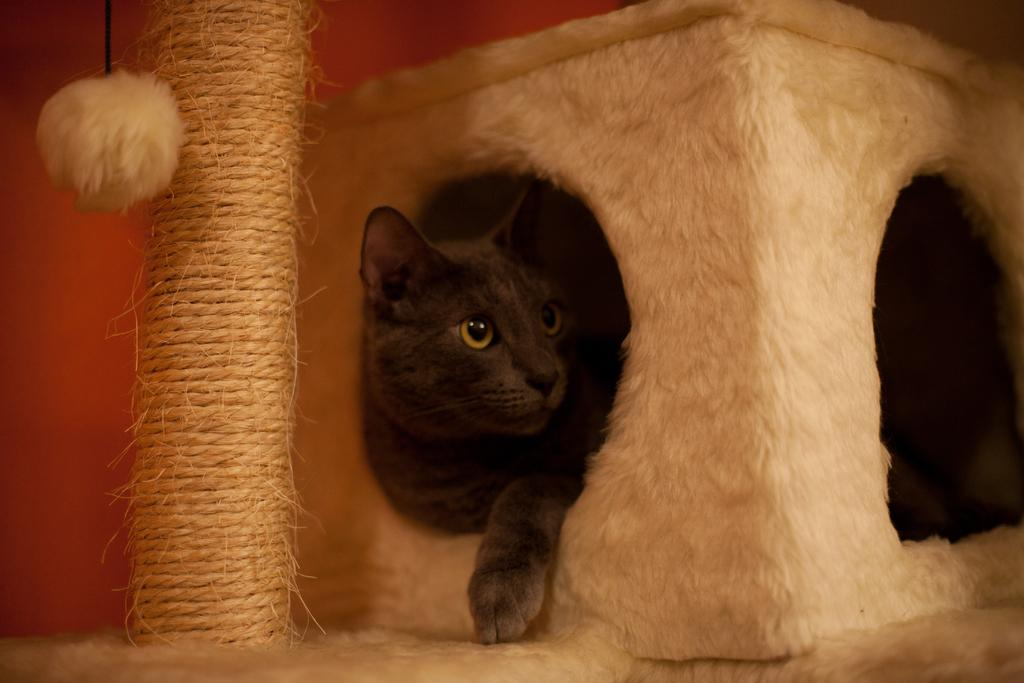What object is present in the image? There is a box in the image. What is inside the box? There is a cat in the box. What can be seen behind the box? There is a wall behind the box. What type of kettle is sitting on the cat's head in the image? There is no kettle present in the image, and the cat's head is not mentioned in the provided facts. 